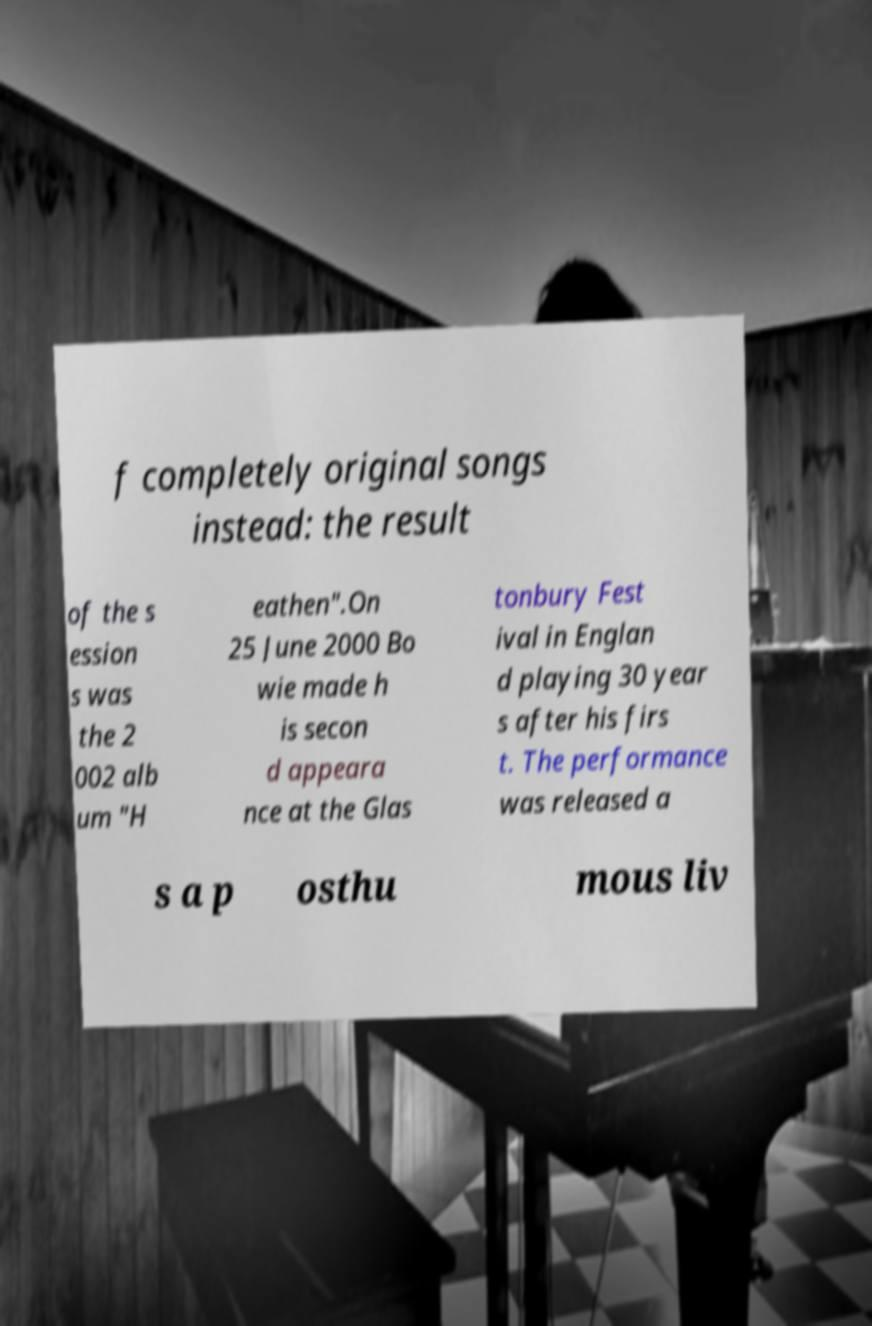Please identify and transcribe the text found in this image. f completely original songs instead: the result of the s ession s was the 2 002 alb um "H eathen".On 25 June 2000 Bo wie made h is secon d appeara nce at the Glas tonbury Fest ival in Englan d playing 30 year s after his firs t. The performance was released a s a p osthu mous liv 